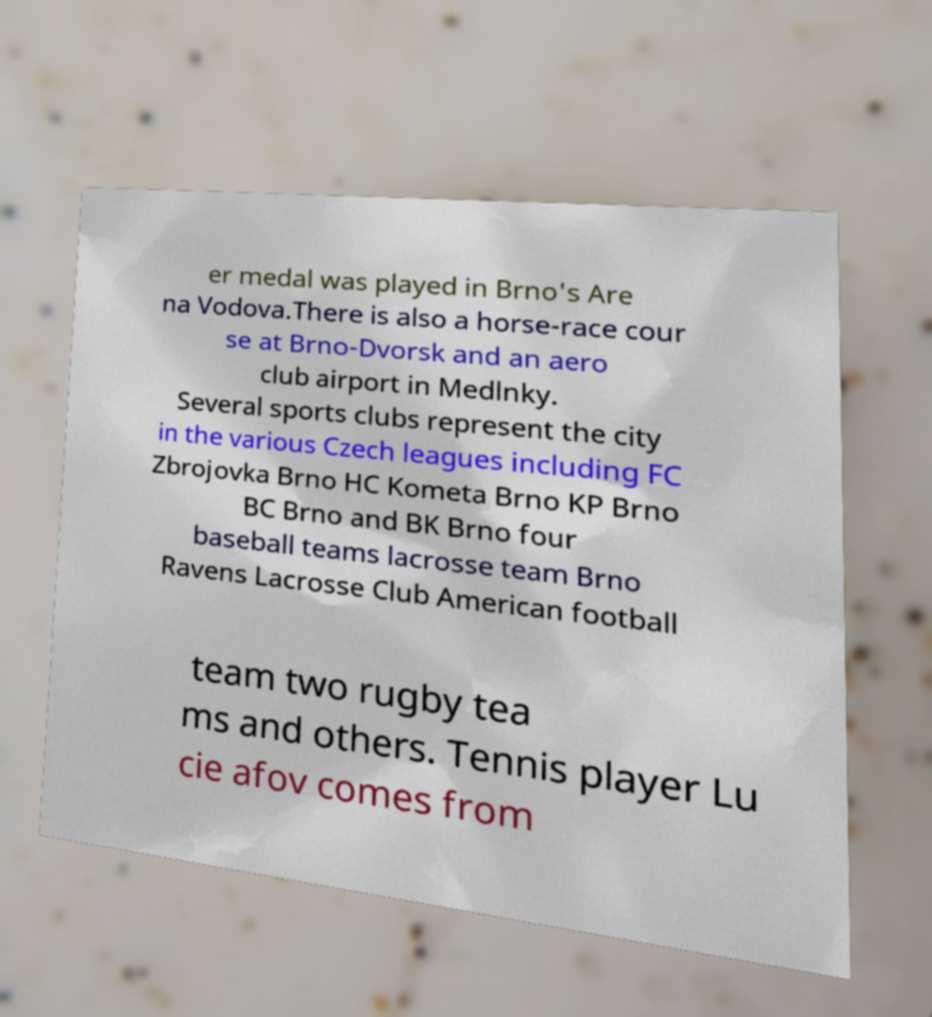Could you assist in decoding the text presented in this image and type it out clearly? er medal was played in Brno's Are na Vodova.There is also a horse-race cour se at Brno-Dvorsk and an aero club airport in Medlnky. Several sports clubs represent the city in the various Czech leagues including FC Zbrojovka Brno HC Kometa Brno KP Brno BC Brno and BK Brno four baseball teams lacrosse team Brno Ravens Lacrosse Club American football team two rugby tea ms and others. Tennis player Lu cie afov comes from 